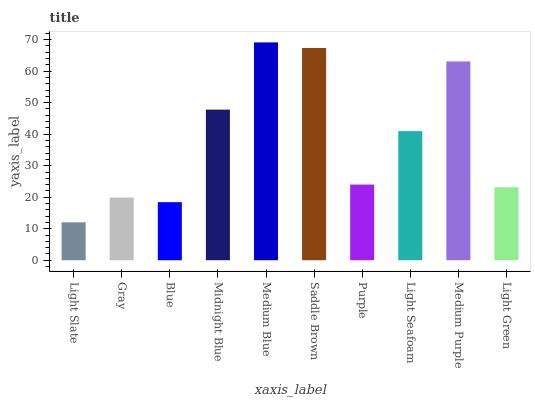Is Light Slate the minimum?
Answer yes or no. Yes. Is Medium Blue the maximum?
Answer yes or no. Yes. Is Gray the minimum?
Answer yes or no. No. Is Gray the maximum?
Answer yes or no. No. Is Gray greater than Light Slate?
Answer yes or no. Yes. Is Light Slate less than Gray?
Answer yes or no. Yes. Is Light Slate greater than Gray?
Answer yes or no. No. Is Gray less than Light Slate?
Answer yes or no. No. Is Light Seafoam the high median?
Answer yes or no. Yes. Is Purple the low median?
Answer yes or no. Yes. Is Gray the high median?
Answer yes or no. No. Is Blue the low median?
Answer yes or no. No. 